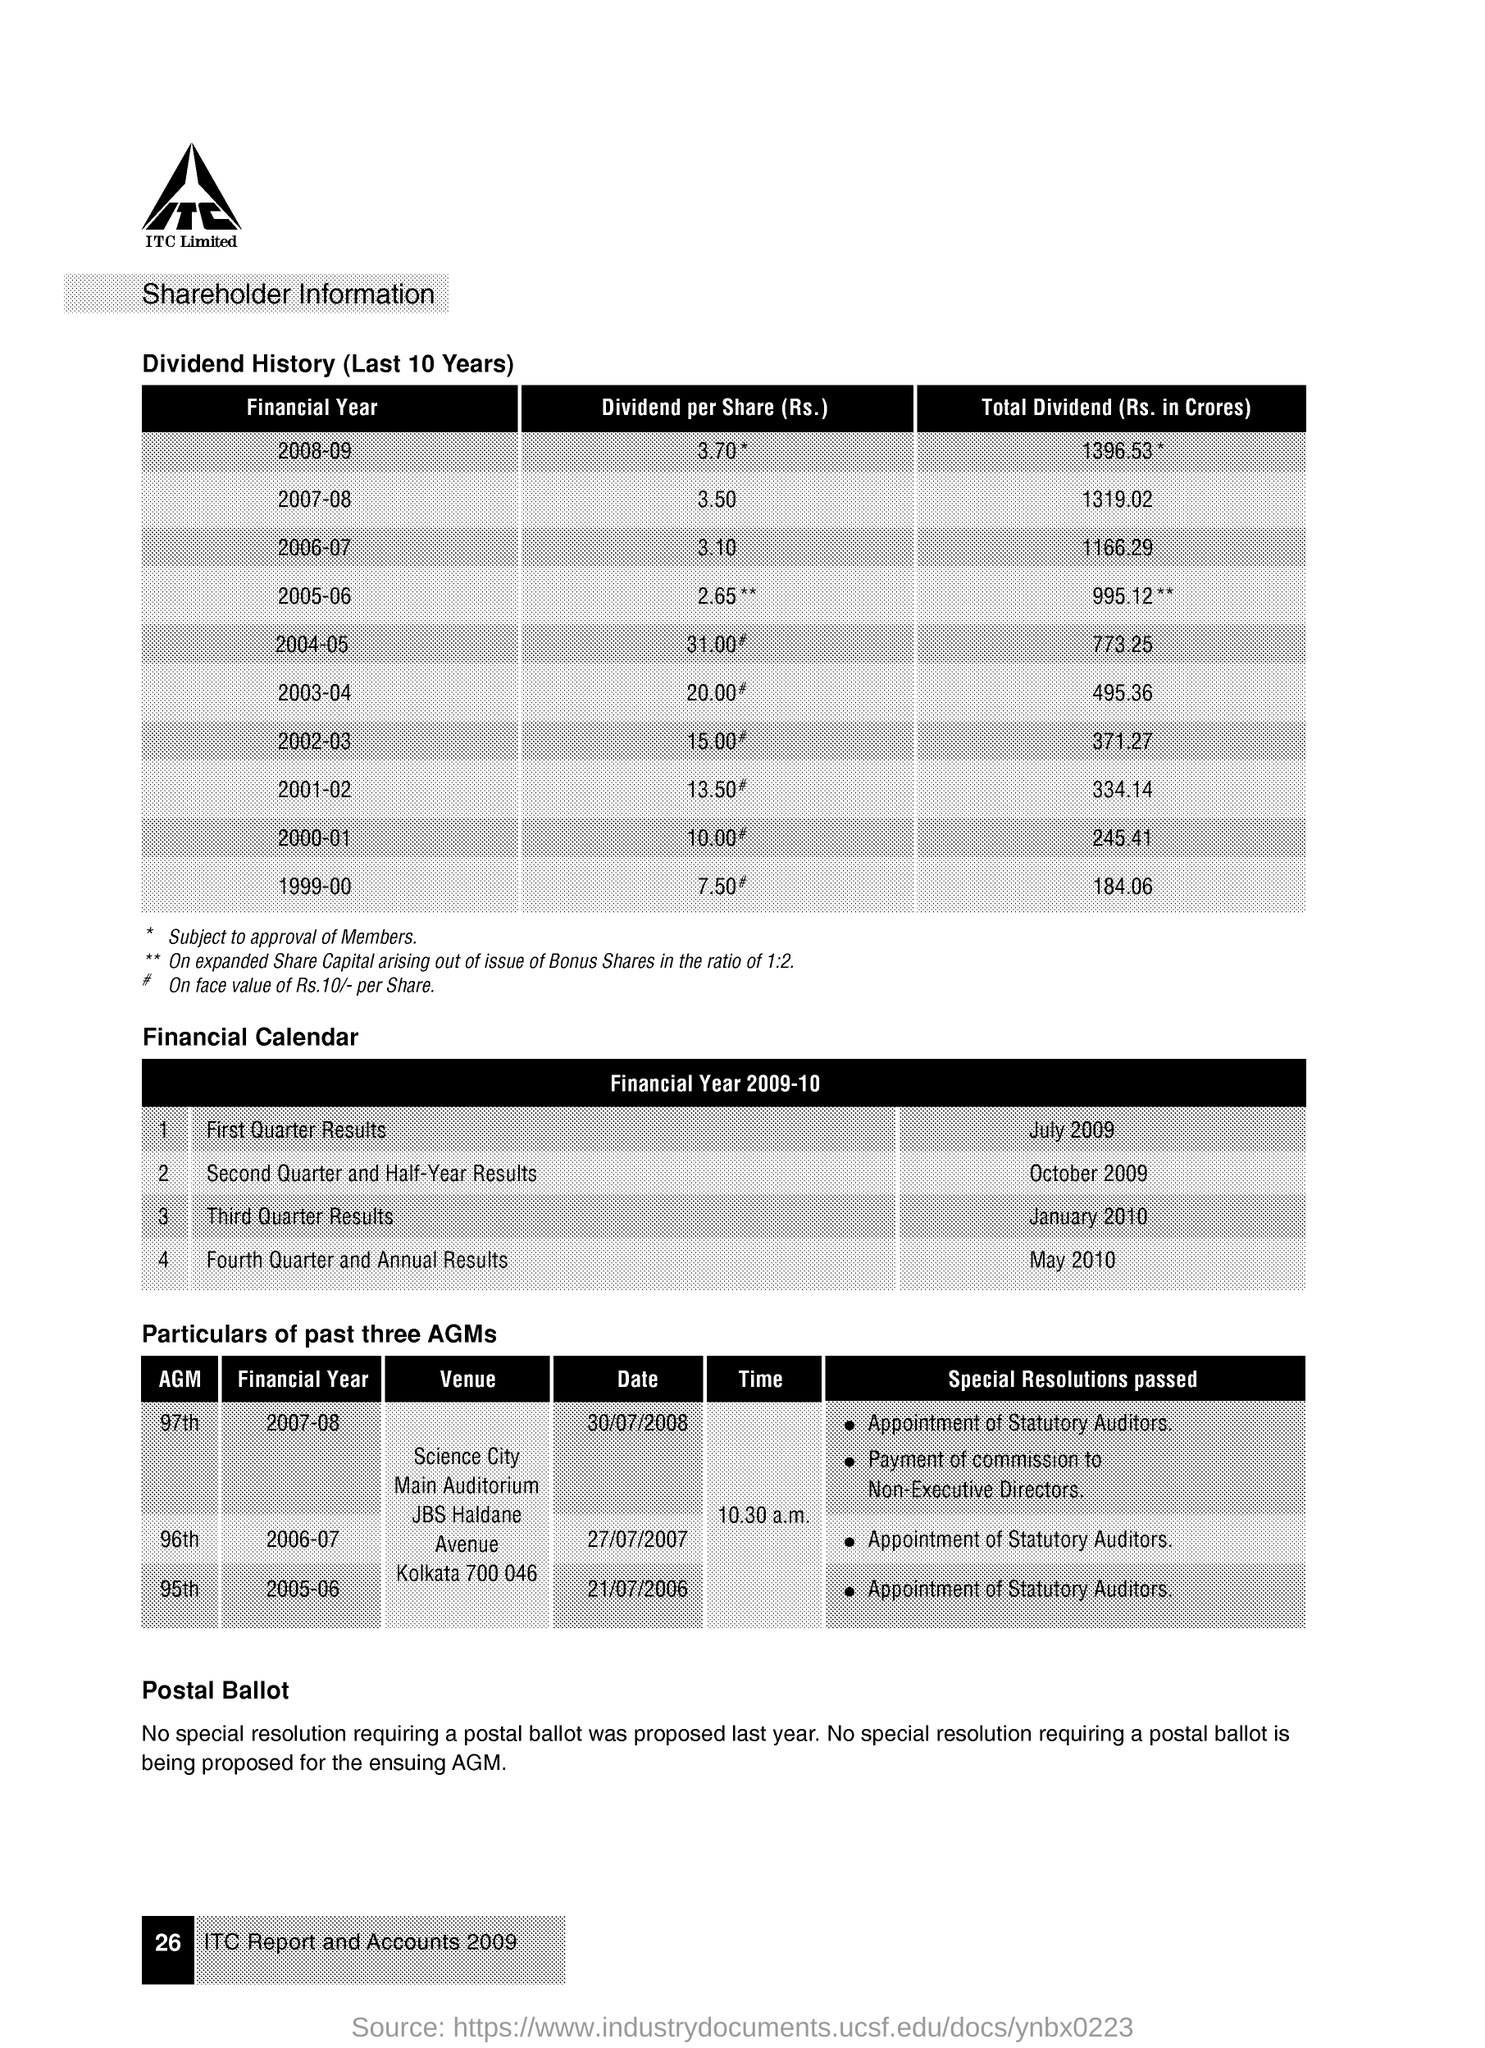What can you infer about the company's performance just by looking at the dividends history provided in the image? From the dividends history, we can infer that the company has had a gradual and consistent increase in dividends per share over the last 10 years, which suggests a stable growth in profitability and a strong financial performance, especially given the significant dividend amounts paid to shareholders. 